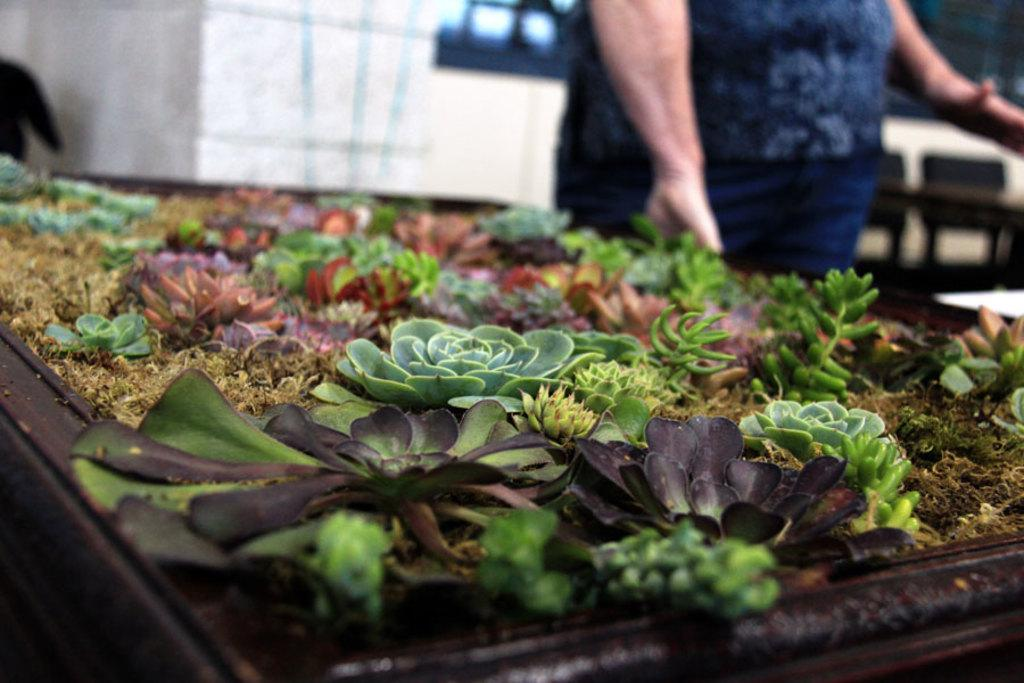What is the main subject in the center of the image? There are plants on a stand in the center of the image. Can you describe the person in the image? There is a person standing in the background of the image. What can be seen behind the person? There is a wall visible in the background of the image. What type of fruit is hanging from the top of the wall in the image? There is no fruit visible in the image, and the wall is not described as having anything hanging from it. 